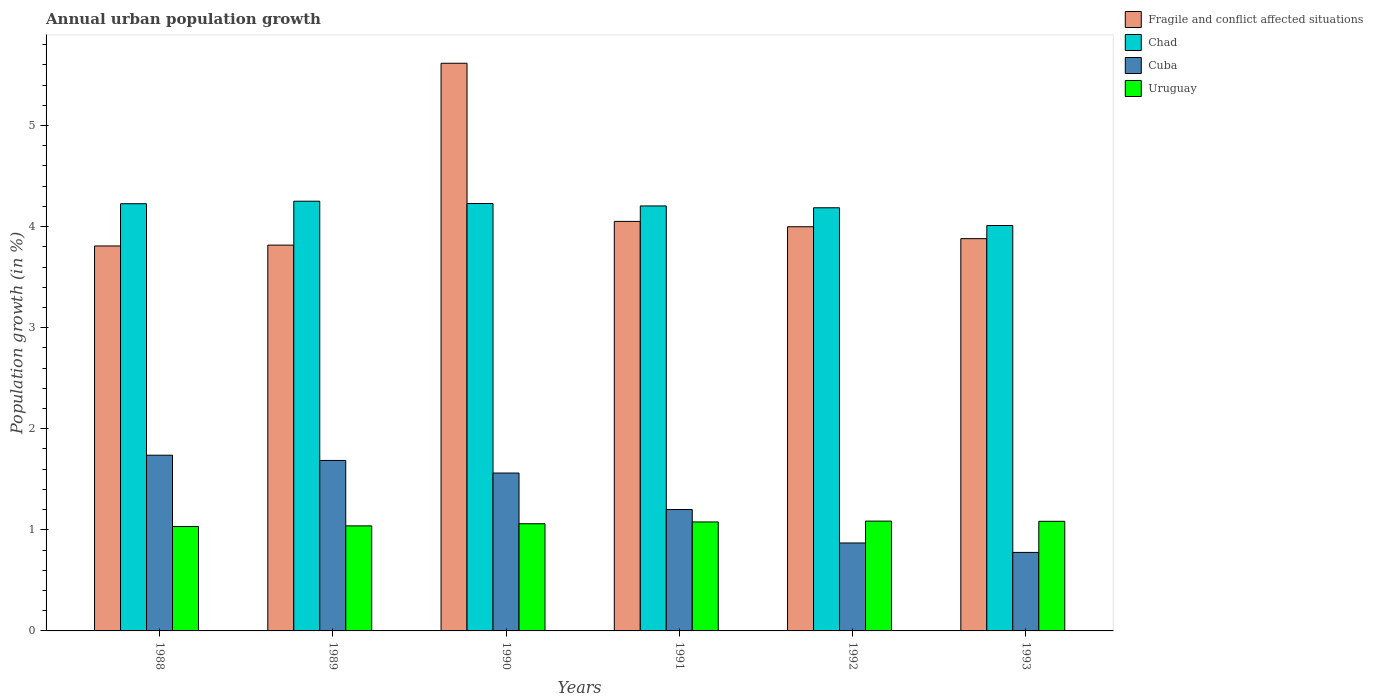How many groups of bars are there?
Your response must be concise. 6. How many bars are there on the 6th tick from the left?
Offer a terse response. 4. How many bars are there on the 6th tick from the right?
Your answer should be compact. 4. What is the label of the 3rd group of bars from the left?
Your response must be concise. 1990. In how many cases, is the number of bars for a given year not equal to the number of legend labels?
Offer a terse response. 0. What is the percentage of urban population growth in Cuba in 1988?
Keep it short and to the point. 1.74. Across all years, what is the maximum percentage of urban population growth in Fragile and conflict affected situations?
Your answer should be compact. 5.62. Across all years, what is the minimum percentage of urban population growth in Uruguay?
Offer a terse response. 1.03. In which year was the percentage of urban population growth in Uruguay maximum?
Offer a terse response. 1992. What is the total percentage of urban population growth in Chad in the graph?
Provide a succinct answer. 25.11. What is the difference between the percentage of urban population growth in Cuba in 1991 and that in 1993?
Ensure brevity in your answer.  0.42. What is the difference between the percentage of urban population growth in Uruguay in 1991 and the percentage of urban population growth in Chad in 1990?
Make the answer very short. -3.15. What is the average percentage of urban population growth in Uruguay per year?
Your response must be concise. 1.06. In the year 1991, what is the difference between the percentage of urban population growth in Uruguay and percentage of urban population growth in Chad?
Your answer should be very brief. -3.13. What is the ratio of the percentage of urban population growth in Uruguay in 1989 to that in 1991?
Your answer should be compact. 0.96. What is the difference between the highest and the second highest percentage of urban population growth in Uruguay?
Ensure brevity in your answer.  0. What is the difference between the highest and the lowest percentage of urban population growth in Uruguay?
Offer a terse response. 0.05. In how many years, is the percentage of urban population growth in Uruguay greater than the average percentage of urban population growth in Uruguay taken over all years?
Give a very brief answer. 3. What does the 4th bar from the left in 1990 represents?
Make the answer very short. Uruguay. What does the 4th bar from the right in 1988 represents?
Your answer should be very brief. Fragile and conflict affected situations. How many bars are there?
Keep it short and to the point. 24. Does the graph contain grids?
Your response must be concise. No. How many legend labels are there?
Ensure brevity in your answer.  4. How are the legend labels stacked?
Give a very brief answer. Vertical. What is the title of the graph?
Offer a very short reply. Annual urban population growth. What is the label or title of the Y-axis?
Make the answer very short. Population growth (in %). What is the Population growth (in %) of Fragile and conflict affected situations in 1988?
Offer a terse response. 3.81. What is the Population growth (in %) of Chad in 1988?
Provide a succinct answer. 4.23. What is the Population growth (in %) of Cuba in 1988?
Give a very brief answer. 1.74. What is the Population growth (in %) of Uruguay in 1988?
Provide a succinct answer. 1.03. What is the Population growth (in %) of Fragile and conflict affected situations in 1989?
Your response must be concise. 3.82. What is the Population growth (in %) of Chad in 1989?
Your answer should be very brief. 4.25. What is the Population growth (in %) of Cuba in 1989?
Your answer should be very brief. 1.69. What is the Population growth (in %) of Uruguay in 1989?
Offer a terse response. 1.04. What is the Population growth (in %) in Fragile and conflict affected situations in 1990?
Offer a terse response. 5.62. What is the Population growth (in %) in Chad in 1990?
Provide a succinct answer. 4.23. What is the Population growth (in %) of Cuba in 1990?
Your answer should be compact. 1.56. What is the Population growth (in %) in Uruguay in 1990?
Offer a very short reply. 1.06. What is the Population growth (in %) of Fragile and conflict affected situations in 1991?
Offer a very short reply. 4.05. What is the Population growth (in %) in Chad in 1991?
Provide a short and direct response. 4.2. What is the Population growth (in %) in Cuba in 1991?
Offer a terse response. 1.2. What is the Population growth (in %) of Uruguay in 1991?
Ensure brevity in your answer.  1.08. What is the Population growth (in %) in Fragile and conflict affected situations in 1992?
Your answer should be compact. 4. What is the Population growth (in %) in Chad in 1992?
Give a very brief answer. 4.19. What is the Population growth (in %) in Cuba in 1992?
Keep it short and to the point. 0.87. What is the Population growth (in %) in Uruguay in 1992?
Ensure brevity in your answer.  1.09. What is the Population growth (in %) of Fragile and conflict affected situations in 1993?
Offer a terse response. 3.88. What is the Population growth (in %) in Chad in 1993?
Provide a succinct answer. 4.01. What is the Population growth (in %) in Cuba in 1993?
Provide a short and direct response. 0.78. What is the Population growth (in %) in Uruguay in 1993?
Make the answer very short. 1.08. Across all years, what is the maximum Population growth (in %) of Fragile and conflict affected situations?
Your answer should be very brief. 5.62. Across all years, what is the maximum Population growth (in %) in Chad?
Offer a very short reply. 4.25. Across all years, what is the maximum Population growth (in %) in Cuba?
Your answer should be very brief. 1.74. Across all years, what is the maximum Population growth (in %) in Uruguay?
Provide a short and direct response. 1.09. Across all years, what is the minimum Population growth (in %) of Fragile and conflict affected situations?
Ensure brevity in your answer.  3.81. Across all years, what is the minimum Population growth (in %) of Chad?
Give a very brief answer. 4.01. Across all years, what is the minimum Population growth (in %) in Cuba?
Provide a succinct answer. 0.78. Across all years, what is the minimum Population growth (in %) of Uruguay?
Provide a succinct answer. 1.03. What is the total Population growth (in %) of Fragile and conflict affected situations in the graph?
Offer a terse response. 25.17. What is the total Population growth (in %) in Chad in the graph?
Your response must be concise. 25.11. What is the total Population growth (in %) in Cuba in the graph?
Make the answer very short. 7.83. What is the total Population growth (in %) in Uruguay in the graph?
Give a very brief answer. 6.38. What is the difference between the Population growth (in %) of Fragile and conflict affected situations in 1988 and that in 1989?
Ensure brevity in your answer.  -0.01. What is the difference between the Population growth (in %) of Chad in 1988 and that in 1989?
Offer a very short reply. -0.02. What is the difference between the Population growth (in %) of Cuba in 1988 and that in 1989?
Keep it short and to the point. 0.05. What is the difference between the Population growth (in %) of Uruguay in 1988 and that in 1989?
Provide a short and direct response. -0.01. What is the difference between the Population growth (in %) in Fragile and conflict affected situations in 1988 and that in 1990?
Provide a short and direct response. -1.81. What is the difference between the Population growth (in %) of Chad in 1988 and that in 1990?
Keep it short and to the point. -0. What is the difference between the Population growth (in %) of Cuba in 1988 and that in 1990?
Provide a succinct answer. 0.18. What is the difference between the Population growth (in %) of Uruguay in 1988 and that in 1990?
Offer a terse response. -0.03. What is the difference between the Population growth (in %) in Fragile and conflict affected situations in 1988 and that in 1991?
Ensure brevity in your answer.  -0.24. What is the difference between the Population growth (in %) of Chad in 1988 and that in 1991?
Provide a short and direct response. 0.02. What is the difference between the Population growth (in %) in Cuba in 1988 and that in 1991?
Make the answer very short. 0.54. What is the difference between the Population growth (in %) of Uruguay in 1988 and that in 1991?
Give a very brief answer. -0.05. What is the difference between the Population growth (in %) in Fragile and conflict affected situations in 1988 and that in 1992?
Provide a short and direct response. -0.19. What is the difference between the Population growth (in %) in Chad in 1988 and that in 1992?
Your answer should be compact. 0.04. What is the difference between the Population growth (in %) of Cuba in 1988 and that in 1992?
Keep it short and to the point. 0.87. What is the difference between the Population growth (in %) of Uruguay in 1988 and that in 1992?
Make the answer very short. -0.05. What is the difference between the Population growth (in %) of Fragile and conflict affected situations in 1988 and that in 1993?
Give a very brief answer. -0.07. What is the difference between the Population growth (in %) in Chad in 1988 and that in 1993?
Provide a succinct answer. 0.22. What is the difference between the Population growth (in %) in Cuba in 1988 and that in 1993?
Provide a short and direct response. 0.96. What is the difference between the Population growth (in %) in Uruguay in 1988 and that in 1993?
Offer a very short reply. -0.05. What is the difference between the Population growth (in %) of Fragile and conflict affected situations in 1989 and that in 1990?
Make the answer very short. -1.8. What is the difference between the Population growth (in %) in Chad in 1989 and that in 1990?
Keep it short and to the point. 0.02. What is the difference between the Population growth (in %) in Cuba in 1989 and that in 1990?
Your answer should be compact. 0.12. What is the difference between the Population growth (in %) of Uruguay in 1989 and that in 1990?
Make the answer very short. -0.02. What is the difference between the Population growth (in %) in Fragile and conflict affected situations in 1989 and that in 1991?
Ensure brevity in your answer.  -0.23. What is the difference between the Population growth (in %) in Chad in 1989 and that in 1991?
Your response must be concise. 0.05. What is the difference between the Population growth (in %) of Cuba in 1989 and that in 1991?
Offer a terse response. 0.49. What is the difference between the Population growth (in %) in Uruguay in 1989 and that in 1991?
Your response must be concise. -0.04. What is the difference between the Population growth (in %) in Fragile and conflict affected situations in 1989 and that in 1992?
Your answer should be compact. -0.18. What is the difference between the Population growth (in %) in Chad in 1989 and that in 1992?
Keep it short and to the point. 0.06. What is the difference between the Population growth (in %) in Cuba in 1989 and that in 1992?
Your answer should be compact. 0.82. What is the difference between the Population growth (in %) in Uruguay in 1989 and that in 1992?
Offer a terse response. -0.05. What is the difference between the Population growth (in %) of Fragile and conflict affected situations in 1989 and that in 1993?
Your response must be concise. -0.06. What is the difference between the Population growth (in %) in Chad in 1989 and that in 1993?
Offer a terse response. 0.24. What is the difference between the Population growth (in %) in Cuba in 1989 and that in 1993?
Provide a short and direct response. 0.91. What is the difference between the Population growth (in %) of Uruguay in 1989 and that in 1993?
Your answer should be compact. -0.05. What is the difference between the Population growth (in %) of Fragile and conflict affected situations in 1990 and that in 1991?
Provide a succinct answer. 1.56. What is the difference between the Population growth (in %) in Chad in 1990 and that in 1991?
Your answer should be compact. 0.02. What is the difference between the Population growth (in %) of Cuba in 1990 and that in 1991?
Your answer should be very brief. 0.36. What is the difference between the Population growth (in %) of Uruguay in 1990 and that in 1991?
Keep it short and to the point. -0.02. What is the difference between the Population growth (in %) in Fragile and conflict affected situations in 1990 and that in 1992?
Provide a short and direct response. 1.62. What is the difference between the Population growth (in %) in Chad in 1990 and that in 1992?
Your response must be concise. 0.04. What is the difference between the Population growth (in %) in Cuba in 1990 and that in 1992?
Provide a short and direct response. 0.69. What is the difference between the Population growth (in %) in Uruguay in 1990 and that in 1992?
Offer a terse response. -0.03. What is the difference between the Population growth (in %) of Fragile and conflict affected situations in 1990 and that in 1993?
Offer a very short reply. 1.74. What is the difference between the Population growth (in %) of Chad in 1990 and that in 1993?
Ensure brevity in your answer.  0.22. What is the difference between the Population growth (in %) in Cuba in 1990 and that in 1993?
Provide a succinct answer. 0.79. What is the difference between the Population growth (in %) of Uruguay in 1990 and that in 1993?
Give a very brief answer. -0.02. What is the difference between the Population growth (in %) of Fragile and conflict affected situations in 1991 and that in 1992?
Provide a short and direct response. 0.05. What is the difference between the Population growth (in %) in Chad in 1991 and that in 1992?
Your answer should be very brief. 0.02. What is the difference between the Population growth (in %) of Cuba in 1991 and that in 1992?
Keep it short and to the point. 0.33. What is the difference between the Population growth (in %) of Uruguay in 1991 and that in 1992?
Make the answer very short. -0.01. What is the difference between the Population growth (in %) in Fragile and conflict affected situations in 1991 and that in 1993?
Your response must be concise. 0.17. What is the difference between the Population growth (in %) in Chad in 1991 and that in 1993?
Offer a terse response. 0.19. What is the difference between the Population growth (in %) of Cuba in 1991 and that in 1993?
Ensure brevity in your answer.  0.42. What is the difference between the Population growth (in %) in Uruguay in 1991 and that in 1993?
Ensure brevity in your answer.  -0.01. What is the difference between the Population growth (in %) in Fragile and conflict affected situations in 1992 and that in 1993?
Ensure brevity in your answer.  0.12. What is the difference between the Population growth (in %) in Chad in 1992 and that in 1993?
Your answer should be compact. 0.18. What is the difference between the Population growth (in %) in Cuba in 1992 and that in 1993?
Provide a short and direct response. 0.09. What is the difference between the Population growth (in %) in Uruguay in 1992 and that in 1993?
Provide a short and direct response. 0. What is the difference between the Population growth (in %) of Fragile and conflict affected situations in 1988 and the Population growth (in %) of Chad in 1989?
Offer a very short reply. -0.44. What is the difference between the Population growth (in %) of Fragile and conflict affected situations in 1988 and the Population growth (in %) of Cuba in 1989?
Your response must be concise. 2.12. What is the difference between the Population growth (in %) of Fragile and conflict affected situations in 1988 and the Population growth (in %) of Uruguay in 1989?
Offer a very short reply. 2.77. What is the difference between the Population growth (in %) in Chad in 1988 and the Population growth (in %) in Cuba in 1989?
Ensure brevity in your answer.  2.54. What is the difference between the Population growth (in %) of Chad in 1988 and the Population growth (in %) of Uruguay in 1989?
Your response must be concise. 3.19. What is the difference between the Population growth (in %) of Cuba in 1988 and the Population growth (in %) of Uruguay in 1989?
Your response must be concise. 0.7. What is the difference between the Population growth (in %) of Fragile and conflict affected situations in 1988 and the Population growth (in %) of Chad in 1990?
Provide a short and direct response. -0.42. What is the difference between the Population growth (in %) of Fragile and conflict affected situations in 1988 and the Population growth (in %) of Cuba in 1990?
Your response must be concise. 2.25. What is the difference between the Population growth (in %) of Fragile and conflict affected situations in 1988 and the Population growth (in %) of Uruguay in 1990?
Provide a short and direct response. 2.75. What is the difference between the Population growth (in %) in Chad in 1988 and the Population growth (in %) in Cuba in 1990?
Offer a terse response. 2.66. What is the difference between the Population growth (in %) of Chad in 1988 and the Population growth (in %) of Uruguay in 1990?
Provide a short and direct response. 3.17. What is the difference between the Population growth (in %) of Cuba in 1988 and the Population growth (in %) of Uruguay in 1990?
Your answer should be very brief. 0.68. What is the difference between the Population growth (in %) of Fragile and conflict affected situations in 1988 and the Population growth (in %) of Chad in 1991?
Your answer should be very brief. -0.4. What is the difference between the Population growth (in %) in Fragile and conflict affected situations in 1988 and the Population growth (in %) in Cuba in 1991?
Offer a very short reply. 2.61. What is the difference between the Population growth (in %) of Fragile and conflict affected situations in 1988 and the Population growth (in %) of Uruguay in 1991?
Keep it short and to the point. 2.73. What is the difference between the Population growth (in %) of Chad in 1988 and the Population growth (in %) of Cuba in 1991?
Ensure brevity in your answer.  3.03. What is the difference between the Population growth (in %) of Chad in 1988 and the Population growth (in %) of Uruguay in 1991?
Keep it short and to the point. 3.15. What is the difference between the Population growth (in %) of Cuba in 1988 and the Population growth (in %) of Uruguay in 1991?
Your answer should be compact. 0.66. What is the difference between the Population growth (in %) in Fragile and conflict affected situations in 1988 and the Population growth (in %) in Chad in 1992?
Keep it short and to the point. -0.38. What is the difference between the Population growth (in %) of Fragile and conflict affected situations in 1988 and the Population growth (in %) of Cuba in 1992?
Give a very brief answer. 2.94. What is the difference between the Population growth (in %) in Fragile and conflict affected situations in 1988 and the Population growth (in %) in Uruguay in 1992?
Ensure brevity in your answer.  2.72. What is the difference between the Population growth (in %) of Chad in 1988 and the Population growth (in %) of Cuba in 1992?
Provide a short and direct response. 3.36. What is the difference between the Population growth (in %) of Chad in 1988 and the Population growth (in %) of Uruguay in 1992?
Provide a short and direct response. 3.14. What is the difference between the Population growth (in %) of Cuba in 1988 and the Population growth (in %) of Uruguay in 1992?
Provide a short and direct response. 0.65. What is the difference between the Population growth (in %) in Fragile and conflict affected situations in 1988 and the Population growth (in %) in Chad in 1993?
Provide a succinct answer. -0.2. What is the difference between the Population growth (in %) in Fragile and conflict affected situations in 1988 and the Population growth (in %) in Cuba in 1993?
Ensure brevity in your answer.  3.03. What is the difference between the Population growth (in %) of Fragile and conflict affected situations in 1988 and the Population growth (in %) of Uruguay in 1993?
Offer a very short reply. 2.72. What is the difference between the Population growth (in %) of Chad in 1988 and the Population growth (in %) of Cuba in 1993?
Make the answer very short. 3.45. What is the difference between the Population growth (in %) in Chad in 1988 and the Population growth (in %) in Uruguay in 1993?
Give a very brief answer. 3.14. What is the difference between the Population growth (in %) in Cuba in 1988 and the Population growth (in %) in Uruguay in 1993?
Your answer should be compact. 0.65. What is the difference between the Population growth (in %) of Fragile and conflict affected situations in 1989 and the Population growth (in %) of Chad in 1990?
Ensure brevity in your answer.  -0.41. What is the difference between the Population growth (in %) of Fragile and conflict affected situations in 1989 and the Population growth (in %) of Cuba in 1990?
Make the answer very short. 2.26. What is the difference between the Population growth (in %) in Fragile and conflict affected situations in 1989 and the Population growth (in %) in Uruguay in 1990?
Your answer should be very brief. 2.76. What is the difference between the Population growth (in %) of Chad in 1989 and the Population growth (in %) of Cuba in 1990?
Keep it short and to the point. 2.69. What is the difference between the Population growth (in %) of Chad in 1989 and the Population growth (in %) of Uruguay in 1990?
Offer a very short reply. 3.19. What is the difference between the Population growth (in %) of Cuba in 1989 and the Population growth (in %) of Uruguay in 1990?
Your answer should be compact. 0.63. What is the difference between the Population growth (in %) of Fragile and conflict affected situations in 1989 and the Population growth (in %) of Chad in 1991?
Provide a succinct answer. -0.39. What is the difference between the Population growth (in %) of Fragile and conflict affected situations in 1989 and the Population growth (in %) of Cuba in 1991?
Your answer should be very brief. 2.62. What is the difference between the Population growth (in %) in Fragile and conflict affected situations in 1989 and the Population growth (in %) in Uruguay in 1991?
Keep it short and to the point. 2.74. What is the difference between the Population growth (in %) in Chad in 1989 and the Population growth (in %) in Cuba in 1991?
Keep it short and to the point. 3.05. What is the difference between the Population growth (in %) of Chad in 1989 and the Population growth (in %) of Uruguay in 1991?
Your answer should be compact. 3.17. What is the difference between the Population growth (in %) in Cuba in 1989 and the Population growth (in %) in Uruguay in 1991?
Your answer should be compact. 0.61. What is the difference between the Population growth (in %) of Fragile and conflict affected situations in 1989 and the Population growth (in %) of Chad in 1992?
Make the answer very short. -0.37. What is the difference between the Population growth (in %) in Fragile and conflict affected situations in 1989 and the Population growth (in %) in Cuba in 1992?
Provide a succinct answer. 2.95. What is the difference between the Population growth (in %) of Fragile and conflict affected situations in 1989 and the Population growth (in %) of Uruguay in 1992?
Ensure brevity in your answer.  2.73. What is the difference between the Population growth (in %) of Chad in 1989 and the Population growth (in %) of Cuba in 1992?
Offer a very short reply. 3.38. What is the difference between the Population growth (in %) of Chad in 1989 and the Population growth (in %) of Uruguay in 1992?
Offer a terse response. 3.16. What is the difference between the Population growth (in %) of Cuba in 1989 and the Population growth (in %) of Uruguay in 1992?
Your response must be concise. 0.6. What is the difference between the Population growth (in %) of Fragile and conflict affected situations in 1989 and the Population growth (in %) of Chad in 1993?
Your answer should be compact. -0.19. What is the difference between the Population growth (in %) of Fragile and conflict affected situations in 1989 and the Population growth (in %) of Cuba in 1993?
Make the answer very short. 3.04. What is the difference between the Population growth (in %) in Fragile and conflict affected situations in 1989 and the Population growth (in %) in Uruguay in 1993?
Keep it short and to the point. 2.73. What is the difference between the Population growth (in %) in Chad in 1989 and the Population growth (in %) in Cuba in 1993?
Offer a terse response. 3.47. What is the difference between the Population growth (in %) of Chad in 1989 and the Population growth (in %) of Uruguay in 1993?
Make the answer very short. 3.17. What is the difference between the Population growth (in %) of Cuba in 1989 and the Population growth (in %) of Uruguay in 1993?
Offer a very short reply. 0.6. What is the difference between the Population growth (in %) in Fragile and conflict affected situations in 1990 and the Population growth (in %) in Chad in 1991?
Your answer should be very brief. 1.41. What is the difference between the Population growth (in %) in Fragile and conflict affected situations in 1990 and the Population growth (in %) in Cuba in 1991?
Make the answer very short. 4.42. What is the difference between the Population growth (in %) in Fragile and conflict affected situations in 1990 and the Population growth (in %) in Uruguay in 1991?
Ensure brevity in your answer.  4.54. What is the difference between the Population growth (in %) in Chad in 1990 and the Population growth (in %) in Cuba in 1991?
Keep it short and to the point. 3.03. What is the difference between the Population growth (in %) in Chad in 1990 and the Population growth (in %) in Uruguay in 1991?
Give a very brief answer. 3.15. What is the difference between the Population growth (in %) of Cuba in 1990 and the Population growth (in %) of Uruguay in 1991?
Keep it short and to the point. 0.48. What is the difference between the Population growth (in %) in Fragile and conflict affected situations in 1990 and the Population growth (in %) in Chad in 1992?
Your response must be concise. 1.43. What is the difference between the Population growth (in %) of Fragile and conflict affected situations in 1990 and the Population growth (in %) of Cuba in 1992?
Provide a succinct answer. 4.75. What is the difference between the Population growth (in %) of Fragile and conflict affected situations in 1990 and the Population growth (in %) of Uruguay in 1992?
Provide a succinct answer. 4.53. What is the difference between the Population growth (in %) in Chad in 1990 and the Population growth (in %) in Cuba in 1992?
Your answer should be compact. 3.36. What is the difference between the Population growth (in %) in Chad in 1990 and the Population growth (in %) in Uruguay in 1992?
Provide a short and direct response. 3.14. What is the difference between the Population growth (in %) in Cuba in 1990 and the Population growth (in %) in Uruguay in 1992?
Your answer should be compact. 0.48. What is the difference between the Population growth (in %) in Fragile and conflict affected situations in 1990 and the Population growth (in %) in Chad in 1993?
Provide a short and direct response. 1.61. What is the difference between the Population growth (in %) in Fragile and conflict affected situations in 1990 and the Population growth (in %) in Cuba in 1993?
Ensure brevity in your answer.  4.84. What is the difference between the Population growth (in %) of Fragile and conflict affected situations in 1990 and the Population growth (in %) of Uruguay in 1993?
Make the answer very short. 4.53. What is the difference between the Population growth (in %) in Chad in 1990 and the Population growth (in %) in Cuba in 1993?
Make the answer very short. 3.45. What is the difference between the Population growth (in %) of Chad in 1990 and the Population growth (in %) of Uruguay in 1993?
Make the answer very short. 3.14. What is the difference between the Population growth (in %) in Cuba in 1990 and the Population growth (in %) in Uruguay in 1993?
Offer a terse response. 0.48. What is the difference between the Population growth (in %) in Fragile and conflict affected situations in 1991 and the Population growth (in %) in Chad in 1992?
Ensure brevity in your answer.  -0.13. What is the difference between the Population growth (in %) in Fragile and conflict affected situations in 1991 and the Population growth (in %) in Cuba in 1992?
Provide a short and direct response. 3.18. What is the difference between the Population growth (in %) of Fragile and conflict affected situations in 1991 and the Population growth (in %) of Uruguay in 1992?
Make the answer very short. 2.97. What is the difference between the Population growth (in %) of Chad in 1991 and the Population growth (in %) of Cuba in 1992?
Offer a very short reply. 3.33. What is the difference between the Population growth (in %) in Chad in 1991 and the Population growth (in %) in Uruguay in 1992?
Make the answer very short. 3.12. What is the difference between the Population growth (in %) of Cuba in 1991 and the Population growth (in %) of Uruguay in 1992?
Keep it short and to the point. 0.11. What is the difference between the Population growth (in %) in Fragile and conflict affected situations in 1991 and the Population growth (in %) in Chad in 1993?
Make the answer very short. 0.04. What is the difference between the Population growth (in %) of Fragile and conflict affected situations in 1991 and the Population growth (in %) of Cuba in 1993?
Offer a terse response. 3.27. What is the difference between the Population growth (in %) in Fragile and conflict affected situations in 1991 and the Population growth (in %) in Uruguay in 1993?
Keep it short and to the point. 2.97. What is the difference between the Population growth (in %) in Chad in 1991 and the Population growth (in %) in Cuba in 1993?
Your answer should be very brief. 3.43. What is the difference between the Population growth (in %) of Chad in 1991 and the Population growth (in %) of Uruguay in 1993?
Offer a terse response. 3.12. What is the difference between the Population growth (in %) of Cuba in 1991 and the Population growth (in %) of Uruguay in 1993?
Your answer should be compact. 0.12. What is the difference between the Population growth (in %) of Fragile and conflict affected situations in 1992 and the Population growth (in %) of Chad in 1993?
Provide a succinct answer. -0.01. What is the difference between the Population growth (in %) in Fragile and conflict affected situations in 1992 and the Population growth (in %) in Cuba in 1993?
Your answer should be very brief. 3.22. What is the difference between the Population growth (in %) in Fragile and conflict affected situations in 1992 and the Population growth (in %) in Uruguay in 1993?
Your response must be concise. 2.91. What is the difference between the Population growth (in %) in Chad in 1992 and the Population growth (in %) in Cuba in 1993?
Provide a short and direct response. 3.41. What is the difference between the Population growth (in %) in Chad in 1992 and the Population growth (in %) in Uruguay in 1993?
Your answer should be compact. 3.1. What is the difference between the Population growth (in %) of Cuba in 1992 and the Population growth (in %) of Uruguay in 1993?
Offer a terse response. -0.21. What is the average Population growth (in %) of Fragile and conflict affected situations per year?
Keep it short and to the point. 4.2. What is the average Population growth (in %) of Chad per year?
Provide a short and direct response. 4.18. What is the average Population growth (in %) of Cuba per year?
Your answer should be very brief. 1.31. What is the average Population growth (in %) in Uruguay per year?
Your answer should be compact. 1.06. In the year 1988, what is the difference between the Population growth (in %) of Fragile and conflict affected situations and Population growth (in %) of Chad?
Provide a succinct answer. -0.42. In the year 1988, what is the difference between the Population growth (in %) of Fragile and conflict affected situations and Population growth (in %) of Cuba?
Your answer should be very brief. 2.07. In the year 1988, what is the difference between the Population growth (in %) of Fragile and conflict affected situations and Population growth (in %) of Uruguay?
Provide a short and direct response. 2.78. In the year 1988, what is the difference between the Population growth (in %) of Chad and Population growth (in %) of Cuba?
Your response must be concise. 2.49. In the year 1988, what is the difference between the Population growth (in %) of Chad and Population growth (in %) of Uruguay?
Your response must be concise. 3.19. In the year 1988, what is the difference between the Population growth (in %) of Cuba and Population growth (in %) of Uruguay?
Provide a succinct answer. 0.71. In the year 1989, what is the difference between the Population growth (in %) of Fragile and conflict affected situations and Population growth (in %) of Chad?
Your answer should be compact. -0.43. In the year 1989, what is the difference between the Population growth (in %) in Fragile and conflict affected situations and Population growth (in %) in Cuba?
Your answer should be compact. 2.13. In the year 1989, what is the difference between the Population growth (in %) in Fragile and conflict affected situations and Population growth (in %) in Uruguay?
Offer a very short reply. 2.78. In the year 1989, what is the difference between the Population growth (in %) in Chad and Population growth (in %) in Cuba?
Your answer should be very brief. 2.56. In the year 1989, what is the difference between the Population growth (in %) of Chad and Population growth (in %) of Uruguay?
Keep it short and to the point. 3.21. In the year 1989, what is the difference between the Population growth (in %) of Cuba and Population growth (in %) of Uruguay?
Give a very brief answer. 0.65. In the year 1990, what is the difference between the Population growth (in %) in Fragile and conflict affected situations and Population growth (in %) in Chad?
Offer a terse response. 1.39. In the year 1990, what is the difference between the Population growth (in %) of Fragile and conflict affected situations and Population growth (in %) of Cuba?
Ensure brevity in your answer.  4.05. In the year 1990, what is the difference between the Population growth (in %) of Fragile and conflict affected situations and Population growth (in %) of Uruguay?
Make the answer very short. 4.56. In the year 1990, what is the difference between the Population growth (in %) of Chad and Population growth (in %) of Cuba?
Provide a short and direct response. 2.67. In the year 1990, what is the difference between the Population growth (in %) of Chad and Population growth (in %) of Uruguay?
Your response must be concise. 3.17. In the year 1990, what is the difference between the Population growth (in %) in Cuba and Population growth (in %) in Uruguay?
Offer a very short reply. 0.5. In the year 1991, what is the difference between the Population growth (in %) in Fragile and conflict affected situations and Population growth (in %) in Chad?
Your response must be concise. -0.15. In the year 1991, what is the difference between the Population growth (in %) in Fragile and conflict affected situations and Population growth (in %) in Cuba?
Offer a very short reply. 2.85. In the year 1991, what is the difference between the Population growth (in %) in Fragile and conflict affected situations and Population growth (in %) in Uruguay?
Keep it short and to the point. 2.97. In the year 1991, what is the difference between the Population growth (in %) of Chad and Population growth (in %) of Cuba?
Keep it short and to the point. 3. In the year 1991, what is the difference between the Population growth (in %) of Chad and Population growth (in %) of Uruguay?
Offer a terse response. 3.13. In the year 1991, what is the difference between the Population growth (in %) in Cuba and Population growth (in %) in Uruguay?
Offer a terse response. 0.12. In the year 1992, what is the difference between the Population growth (in %) of Fragile and conflict affected situations and Population growth (in %) of Chad?
Keep it short and to the point. -0.19. In the year 1992, what is the difference between the Population growth (in %) in Fragile and conflict affected situations and Population growth (in %) in Cuba?
Offer a terse response. 3.13. In the year 1992, what is the difference between the Population growth (in %) of Fragile and conflict affected situations and Population growth (in %) of Uruguay?
Make the answer very short. 2.91. In the year 1992, what is the difference between the Population growth (in %) in Chad and Population growth (in %) in Cuba?
Provide a short and direct response. 3.32. In the year 1992, what is the difference between the Population growth (in %) of Chad and Population growth (in %) of Uruguay?
Your answer should be compact. 3.1. In the year 1992, what is the difference between the Population growth (in %) in Cuba and Population growth (in %) in Uruguay?
Offer a very short reply. -0.22. In the year 1993, what is the difference between the Population growth (in %) of Fragile and conflict affected situations and Population growth (in %) of Chad?
Offer a very short reply. -0.13. In the year 1993, what is the difference between the Population growth (in %) in Fragile and conflict affected situations and Population growth (in %) in Cuba?
Provide a short and direct response. 3.1. In the year 1993, what is the difference between the Population growth (in %) of Fragile and conflict affected situations and Population growth (in %) of Uruguay?
Your answer should be very brief. 2.8. In the year 1993, what is the difference between the Population growth (in %) in Chad and Population growth (in %) in Cuba?
Your response must be concise. 3.23. In the year 1993, what is the difference between the Population growth (in %) in Chad and Population growth (in %) in Uruguay?
Your response must be concise. 2.93. In the year 1993, what is the difference between the Population growth (in %) in Cuba and Population growth (in %) in Uruguay?
Your answer should be very brief. -0.31. What is the ratio of the Population growth (in %) in Fragile and conflict affected situations in 1988 to that in 1989?
Keep it short and to the point. 1. What is the ratio of the Population growth (in %) in Chad in 1988 to that in 1989?
Give a very brief answer. 0.99. What is the ratio of the Population growth (in %) of Cuba in 1988 to that in 1989?
Ensure brevity in your answer.  1.03. What is the ratio of the Population growth (in %) in Fragile and conflict affected situations in 1988 to that in 1990?
Your response must be concise. 0.68. What is the ratio of the Population growth (in %) in Cuba in 1988 to that in 1990?
Make the answer very short. 1.11. What is the ratio of the Population growth (in %) of Uruguay in 1988 to that in 1990?
Provide a short and direct response. 0.97. What is the ratio of the Population growth (in %) of Chad in 1988 to that in 1991?
Make the answer very short. 1.01. What is the ratio of the Population growth (in %) of Cuba in 1988 to that in 1991?
Provide a succinct answer. 1.45. What is the ratio of the Population growth (in %) in Uruguay in 1988 to that in 1991?
Keep it short and to the point. 0.96. What is the ratio of the Population growth (in %) in Chad in 1988 to that in 1992?
Offer a very short reply. 1.01. What is the ratio of the Population growth (in %) in Cuba in 1988 to that in 1992?
Give a very brief answer. 2. What is the ratio of the Population growth (in %) of Uruguay in 1988 to that in 1992?
Ensure brevity in your answer.  0.95. What is the ratio of the Population growth (in %) of Fragile and conflict affected situations in 1988 to that in 1993?
Make the answer very short. 0.98. What is the ratio of the Population growth (in %) in Chad in 1988 to that in 1993?
Make the answer very short. 1.05. What is the ratio of the Population growth (in %) in Cuba in 1988 to that in 1993?
Offer a very short reply. 2.24. What is the ratio of the Population growth (in %) in Uruguay in 1988 to that in 1993?
Your answer should be very brief. 0.95. What is the ratio of the Population growth (in %) of Fragile and conflict affected situations in 1989 to that in 1990?
Offer a very short reply. 0.68. What is the ratio of the Population growth (in %) of Chad in 1989 to that in 1990?
Offer a terse response. 1.01. What is the ratio of the Population growth (in %) of Cuba in 1989 to that in 1990?
Make the answer very short. 1.08. What is the ratio of the Population growth (in %) in Uruguay in 1989 to that in 1990?
Keep it short and to the point. 0.98. What is the ratio of the Population growth (in %) in Fragile and conflict affected situations in 1989 to that in 1991?
Your response must be concise. 0.94. What is the ratio of the Population growth (in %) of Chad in 1989 to that in 1991?
Your answer should be compact. 1.01. What is the ratio of the Population growth (in %) in Cuba in 1989 to that in 1991?
Provide a succinct answer. 1.4. What is the ratio of the Population growth (in %) in Uruguay in 1989 to that in 1991?
Your response must be concise. 0.96. What is the ratio of the Population growth (in %) of Fragile and conflict affected situations in 1989 to that in 1992?
Ensure brevity in your answer.  0.95. What is the ratio of the Population growth (in %) in Chad in 1989 to that in 1992?
Keep it short and to the point. 1.02. What is the ratio of the Population growth (in %) in Cuba in 1989 to that in 1992?
Give a very brief answer. 1.94. What is the ratio of the Population growth (in %) of Uruguay in 1989 to that in 1992?
Offer a terse response. 0.96. What is the ratio of the Population growth (in %) of Fragile and conflict affected situations in 1989 to that in 1993?
Offer a very short reply. 0.98. What is the ratio of the Population growth (in %) in Chad in 1989 to that in 1993?
Offer a terse response. 1.06. What is the ratio of the Population growth (in %) of Cuba in 1989 to that in 1993?
Provide a succinct answer. 2.17. What is the ratio of the Population growth (in %) in Uruguay in 1989 to that in 1993?
Your answer should be compact. 0.96. What is the ratio of the Population growth (in %) in Fragile and conflict affected situations in 1990 to that in 1991?
Offer a very short reply. 1.39. What is the ratio of the Population growth (in %) of Chad in 1990 to that in 1991?
Your answer should be very brief. 1.01. What is the ratio of the Population growth (in %) of Cuba in 1990 to that in 1991?
Your answer should be very brief. 1.3. What is the ratio of the Population growth (in %) of Uruguay in 1990 to that in 1991?
Your answer should be compact. 0.98. What is the ratio of the Population growth (in %) in Fragile and conflict affected situations in 1990 to that in 1992?
Your answer should be very brief. 1.4. What is the ratio of the Population growth (in %) of Chad in 1990 to that in 1992?
Give a very brief answer. 1.01. What is the ratio of the Population growth (in %) in Cuba in 1990 to that in 1992?
Keep it short and to the point. 1.8. What is the ratio of the Population growth (in %) of Uruguay in 1990 to that in 1992?
Your answer should be very brief. 0.98. What is the ratio of the Population growth (in %) of Fragile and conflict affected situations in 1990 to that in 1993?
Offer a terse response. 1.45. What is the ratio of the Population growth (in %) in Chad in 1990 to that in 1993?
Ensure brevity in your answer.  1.05. What is the ratio of the Population growth (in %) of Cuba in 1990 to that in 1993?
Provide a succinct answer. 2.01. What is the ratio of the Population growth (in %) in Uruguay in 1990 to that in 1993?
Offer a very short reply. 0.98. What is the ratio of the Population growth (in %) of Fragile and conflict affected situations in 1991 to that in 1992?
Give a very brief answer. 1.01. What is the ratio of the Population growth (in %) in Cuba in 1991 to that in 1992?
Give a very brief answer. 1.38. What is the ratio of the Population growth (in %) of Uruguay in 1991 to that in 1992?
Your answer should be very brief. 0.99. What is the ratio of the Population growth (in %) of Fragile and conflict affected situations in 1991 to that in 1993?
Your answer should be very brief. 1.04. What is the ratio of the Population growth (in %) of Chad in 1991 to that in 1993?
Your answer should be very brief. 1.05. What is the ratio of the Population growth (in %) in Cuba in 1991 to that in 1993?
Ensure brevity in your answer.  1.55. What is the ratio of the Population growth (in %) in Uruguay in 1991 to that in 1993?
Ensure brevity in your answer.  0.99. What is the ratio of the Population growth (in %) in Fragile and conflict affected situations in 1992 to that in 1993?
Ensure brevity in your answer.  1.03. What is the ratio of the Population growth (in %) in Chad in 1992 to that in 1993?
Provide a succinct answer. 1.04. What is the ratio of the Population growth (in %) in Cuba in 1992 to that in 1993?
Your response must be concise. 1.12. What is the difference between the highest and the second highest Population growth (in %) of Fragile and conflict affected situations?
Your answer should be compact. 1.56. What is the difference between the highest and the second highest Population growth (in %) in Chad?
Provide a short and direct response. 0.02. What is the difference between the highest and the second highest Population growth (in %) of Cuba?
Your answer should be compact. 0.05. What is the difference between the highest and the second highest Population growth (in %) of Uruguay?
Offer a terse response. 0. What is the difference between the highest and the lowest Population growth (in %) in Fragile and conflict affected situations?
Offer a very short reply. 1.81. What is the difference between the highest and the lowest Population growth (in %) of Chad?
Provide a succinct answer. 0.24. What is the difference between the highest and the lowest Population growth (in %) of Cuba?
Make the answer very short. 0.96. What is the difference between the highest and the lowest Population growth (in %) of Uruguay?
Provide a short and direct response. 0.05. 